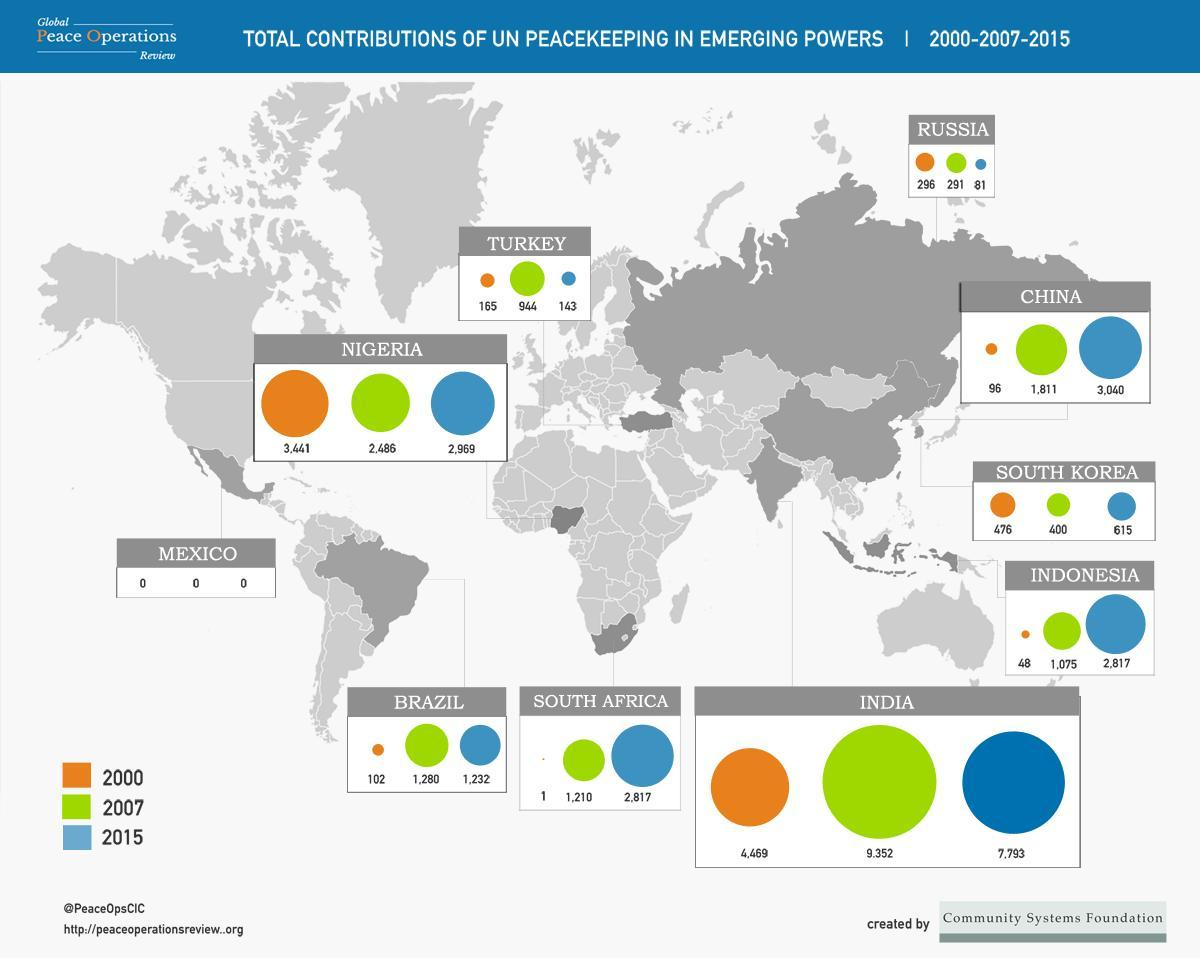which year was the contribution in turkey the second highest
Answer the question with a short phrase. 2000 how much did the count increase in China from 2000 to 2015 2944 Other than India, which other countries have shown a decline in 2015 when compared to 2007 Russia, Turkey, Brazil what was the contribution of UN peacekeeping in Nigeria in 2007 2,486 What is the total period in years considered in this report 15 